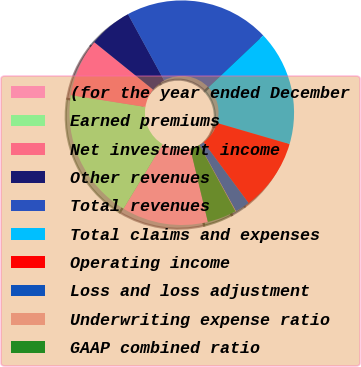Convert chart. <chart><loc_0><loc_0><loc_500><loc_500><pie_chart><fcel>(for the year ended December<fcel>Earned premiums<fcel>Net investment income<fcel>Other revenues<fcel>Total revenues<fcel>Total claims and expenses<fcel>Operating income<fcel>Loss and loss adjustment<fcel>Underwriting expense ratio<fcel>GAAP combined ratio<nl><fcel>12.41%<fcel>18.83%<fcel>8.3%<fcel>6.24%<fcel>20.88%<fcel>16.59%<fcel>10.35%<fcel>2.13%<fcel>0.08%<fcel>4.19%<nl></chart> 